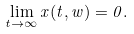Convert formula to latex. <formula><loc_0><loc_0><loc_500><loc_500>\lim _ { t \rightarrow \infty } x ( t , w ) = 0 .</formula> 